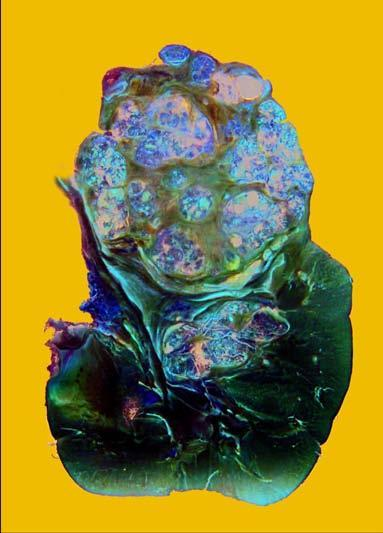what has reniform contour?
Answer the question using a single word or phrase. Rest of the kidney 